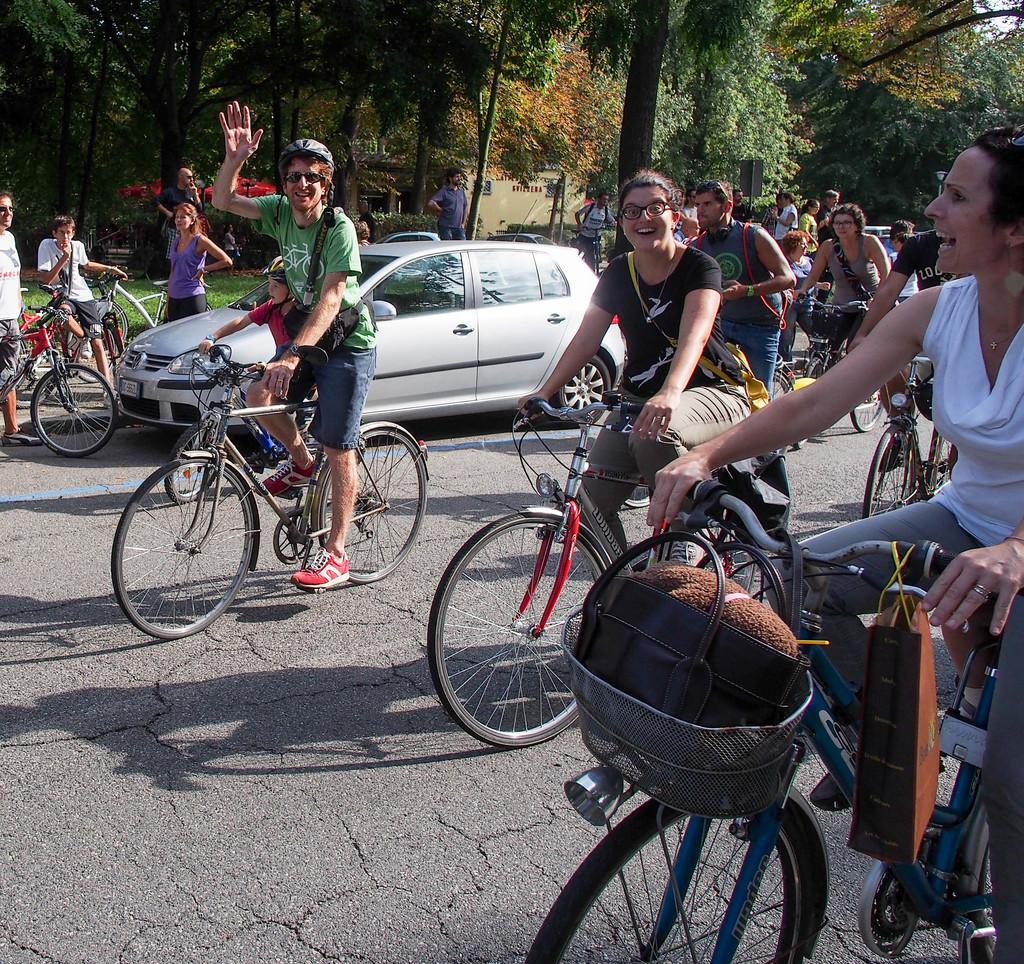What are the persons in the image doing? The persons in the image are on cycles. Can you describe the vehicle parked behind one of the persons? A car is parked behind a person in the image. What type of natural elements can be seen in the image? There are trees in the image. How would you describe the overall setting of the image? The background of the image is filled with greenery. How many turkeys can be seen running up the slope in the image? There are no turkeys or slopes present in the image. What time is indicated by the clocks in the image? There are no clocks visible in the image. 